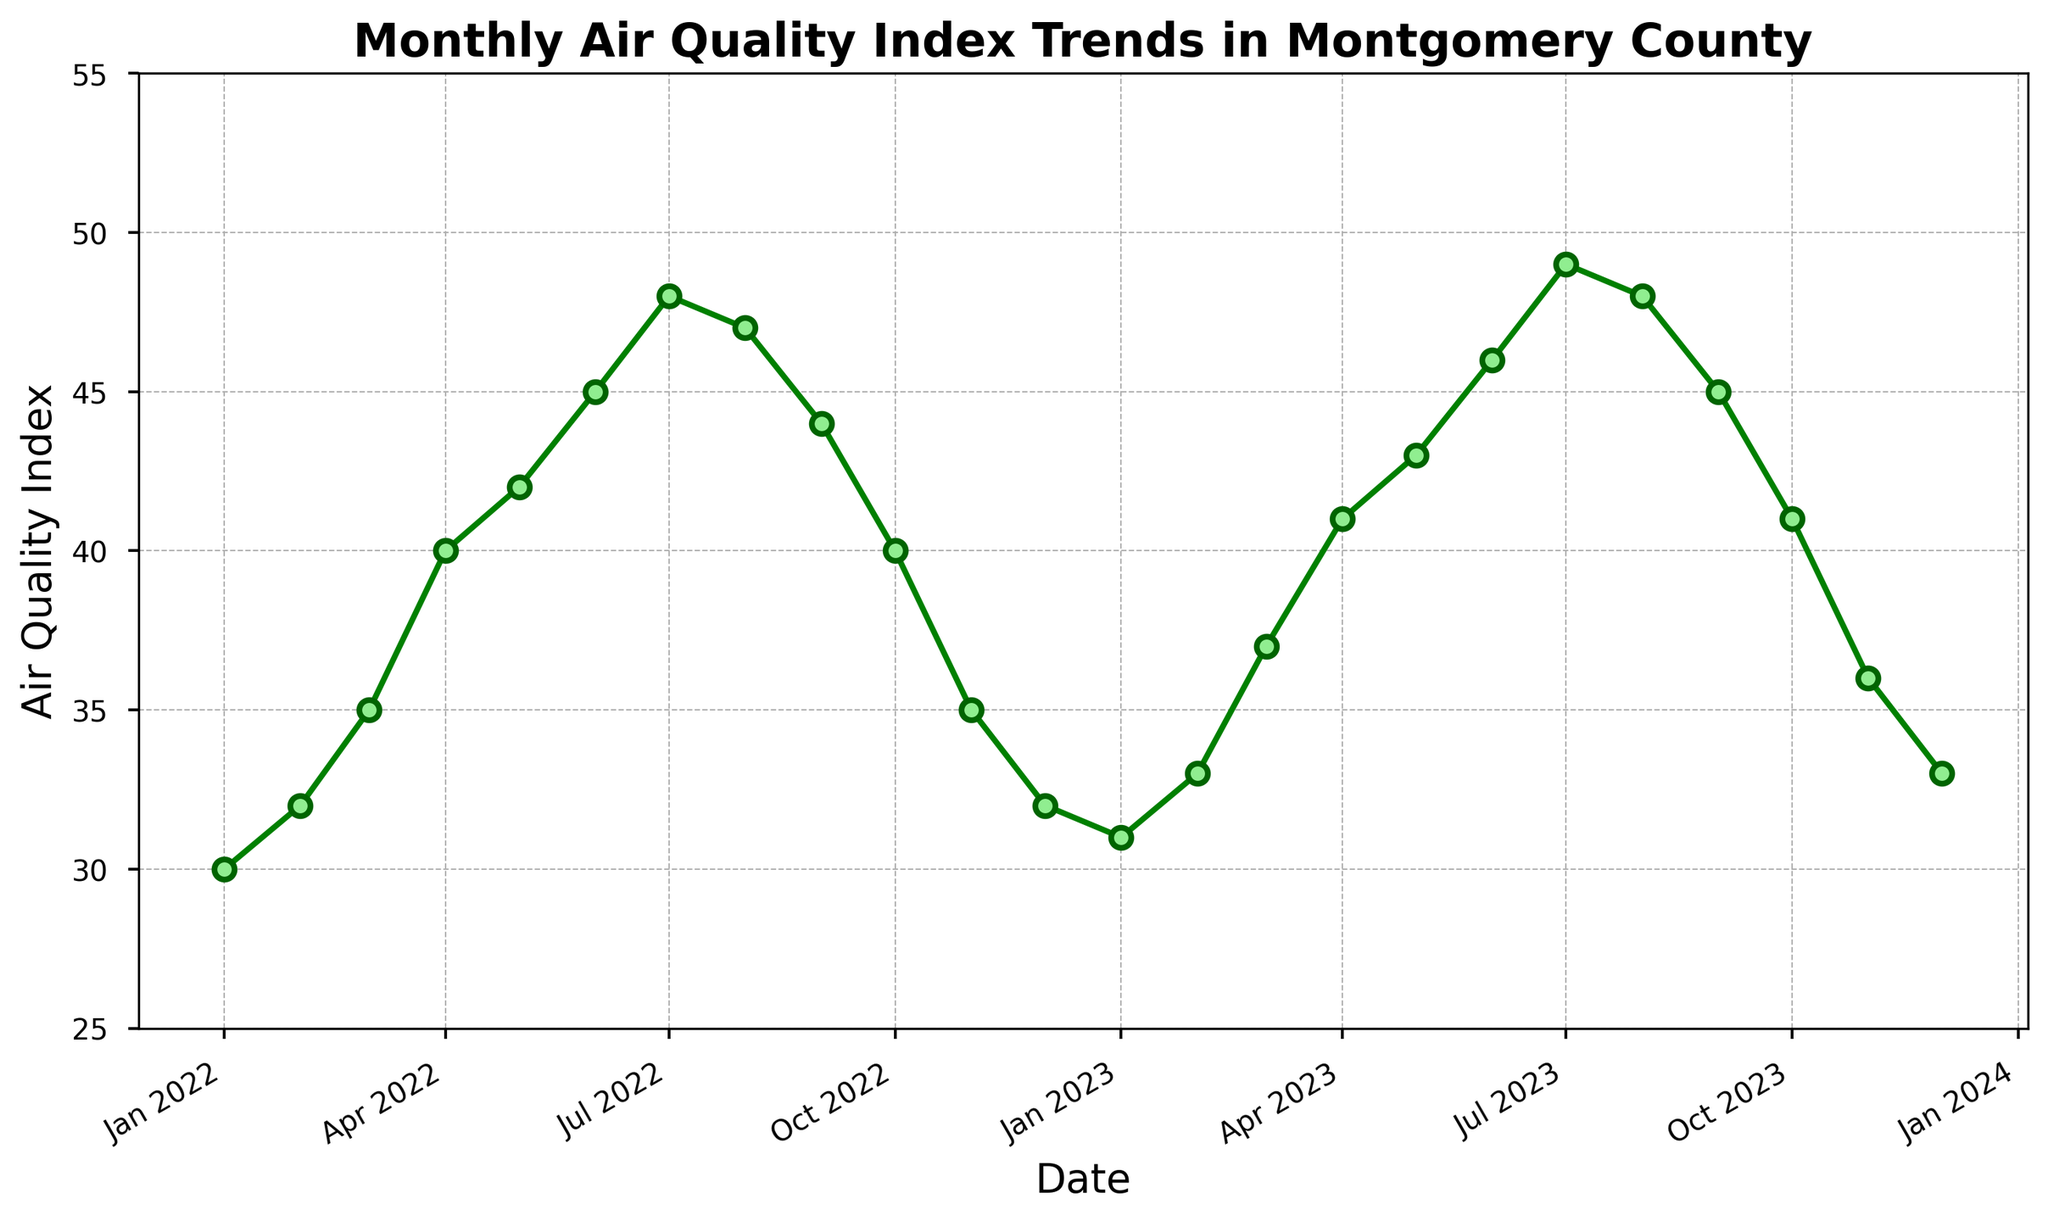What is the general trend of the Air Quality Index from January to December for both years? To see the trend, we need to follow the line plotted each month for both years. Both years start with lower values in January, gradually increase towards mid-year, hitting the highest values in July, and then decrease again towards December.
Answer: Increasing in the first half of the year, peaking in July, decreasing in the second half of the year Which month has the highest Air Quality Index in 2023? Locate the highest point on the line in 2023. The highest value is in July.
Answer: July Is the Air Quality Index higher in June 2023 or June 2022? Compare the data points of June for both years. June 2023 has an index of 46, whereas June 2022 has an index of 45.
Answer: June 2023 What is the average Air Quality Index for the summer months (June, July, August) in 2022? The summer months are June, July, and August. Their values in 2022 are 45, 48, and 47. The average is calculated as (45 + 48 + 47) / 3 = 46.67.
Answer: 46.67 How much does the Air Quality Index change from April to May in both years? For 2022, April to May goes from 40 to 42, so the change is 42 - 40 = 2. For 2023, April to May goes from 41 to 43, so the change is 43 - 41 = 2.
Answer: 2 for both years Which year has a higher Air Quality Index in November? Compare the values for November in both years. November 2022 has an index of 35, whereas November 2023 has an index of 36.
Answer: 2023 What is the difference between the highest and lowest Air Quality Index in 2022? The highest value in 2022 is 48 (July) and the lowest is 30 (January). The difference is 48 - 30 = 18.
Answer: 18 Is the Air Quality Index trend similar between the two years? Observe the plotted lines for both years, which show a similar pattern: low at the start and end, peaking in the middle.
Answer: Yes Which month shows a decrease in the Air Quality Index compared to the previous month in 2023? Check each month's value. August to September drops from 48 to 45.
Answer: September 